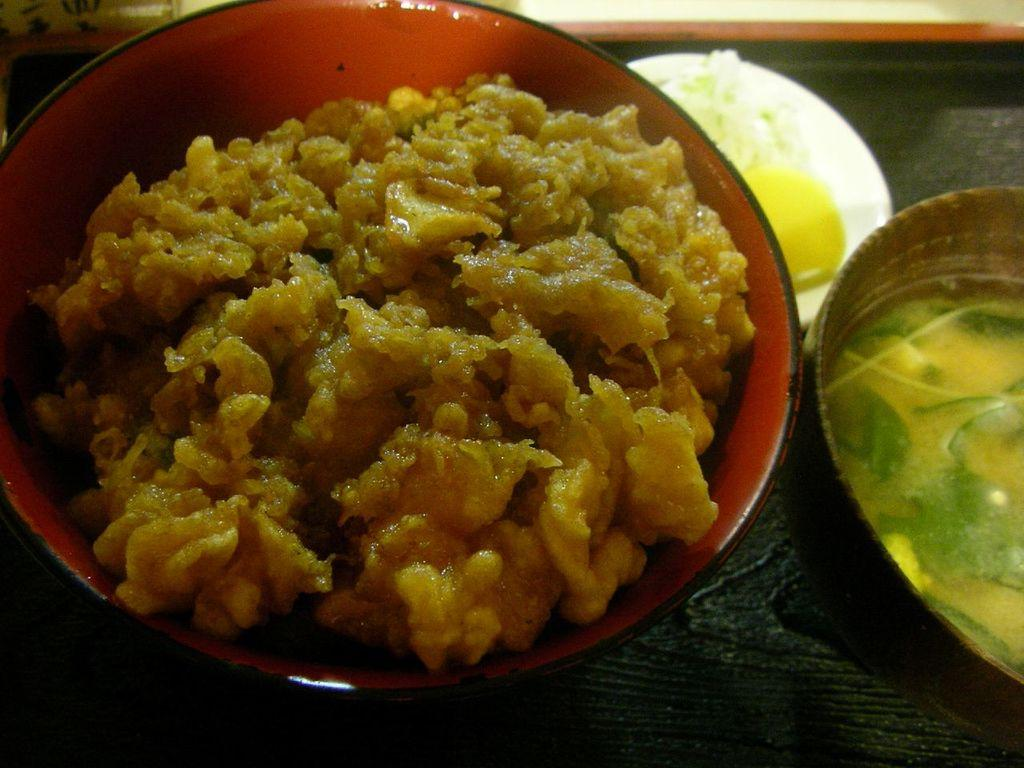What type of food can be seen in the image? There are food items in the image, including soup. How are the food items and soup presented in the image? The food items and soup are in bowls. Where are the bowls located in the image? The bowls are on a platform. What else is on the platform in the image? There are items in a plate on the platform. Can you see a friend swimming in the ocean in the image? There is no ocean or friend present in the image; it features food items and soup in bowls on a platform. 